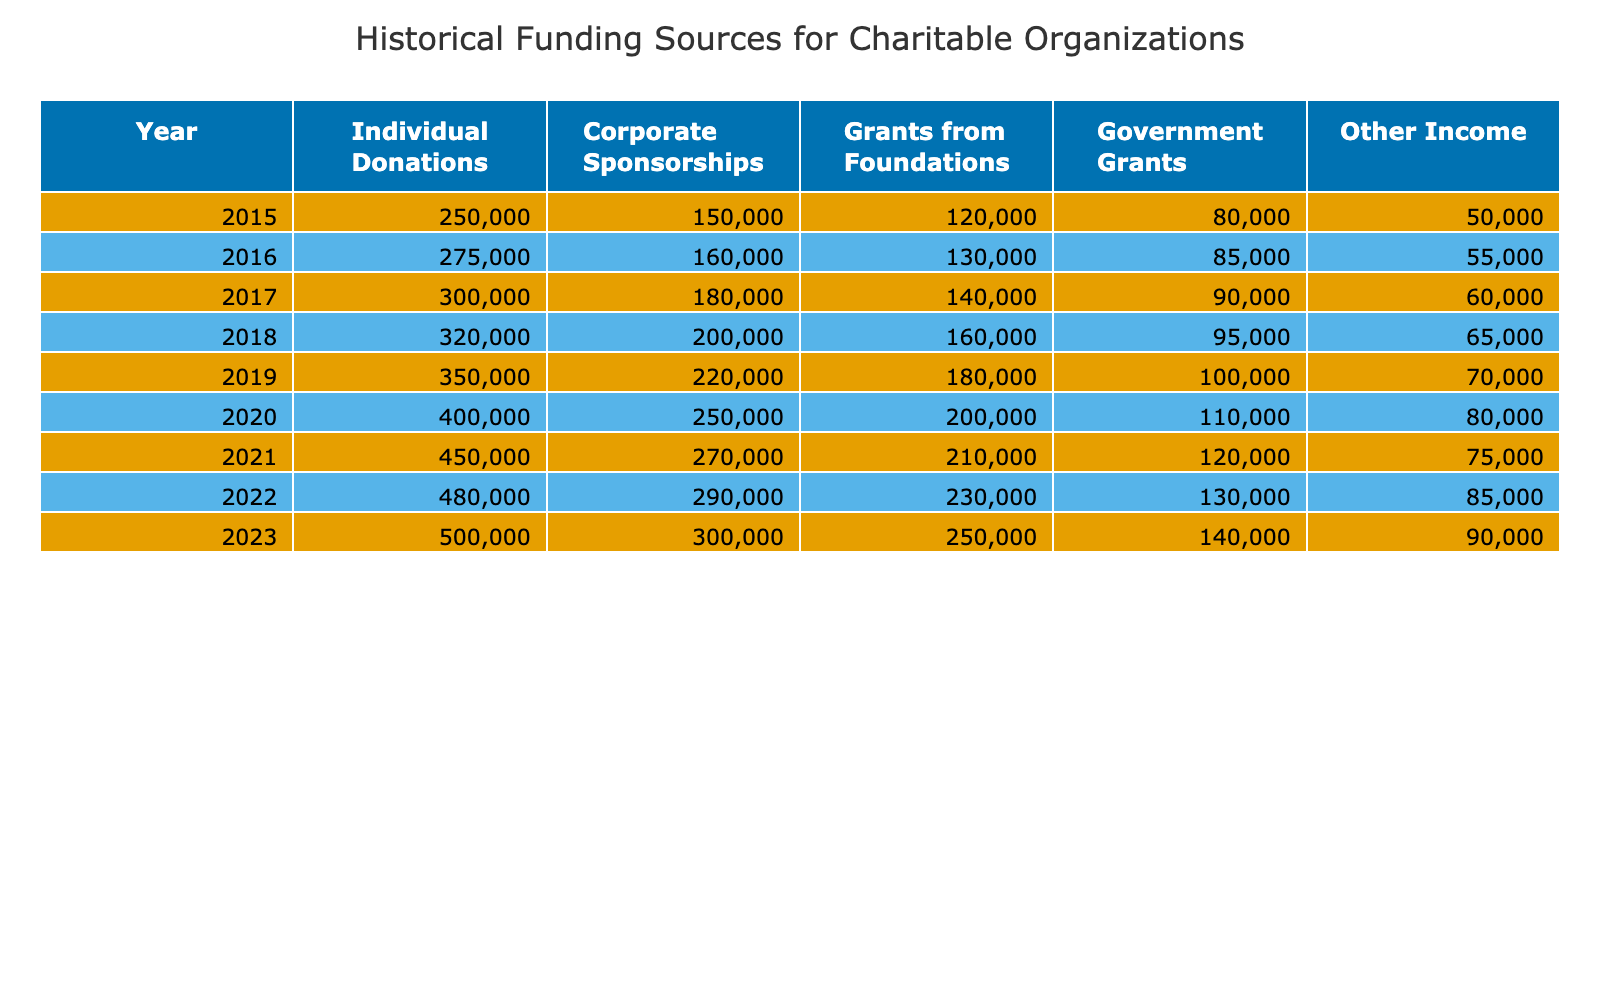What was the total amount of Individual Donations in 2020? According to the table, the Individual Donations for the year 2020 was listed as 400,000.
Answer: 400,000 What was the highest amount received from Corporate Sponsorships, and in what year did this occur? By examining the Corporate Sponsorships column, the highest amount is 300,000, which occurred in 2023.
Answer: 300,000 in 2023 What is the average Government Grants from 2015 to 2023? To find the average, we first sum the Government Grants for each year: 80,000 + 85,000 + 90,000 + 95,000 + 100,000 + 110,000 + 120,000 + 130,000 + 140,000 = 1,020,000. There are 9 years, so we divide 1,020,000 by 9 to get approximately 113,333.
Answer: 113,333 In which year was the total income (sum of all sources) the highest, and what was that amount? To find this, we need to calculate the total for each year by summing across all funding sources. The totals for each year are: 650,000 (2015), 660,000 (2016), 715,000 (2017), 795,000 (2018), 1,000,000 (2019), 1,060,000 (2020), 1,050,000 (2021), 1,175,000 (2022), and 1,190,000 (2023). The highest total is 1,190,000 in 2023.
Answer: 2023 with 1,190,000 Were Government Grants consistently increasing from 2015 to 2023? By examining the Government Grants column from 2015 to 2023, we see it increased each year: 80,000 in 2015, 85,000 in 2016, and so on, reaching 140,000 in 2023. This confirms a consistent increase.
Answer: Yes What was the difference in total funding between 2015 and 2023? The total funding for 2015 is 650,000 and for 2023 is 1,190,000. The difference is calculated as follows: 1,190,000 - 650,000 = 540,000.
Answer: 540,000 